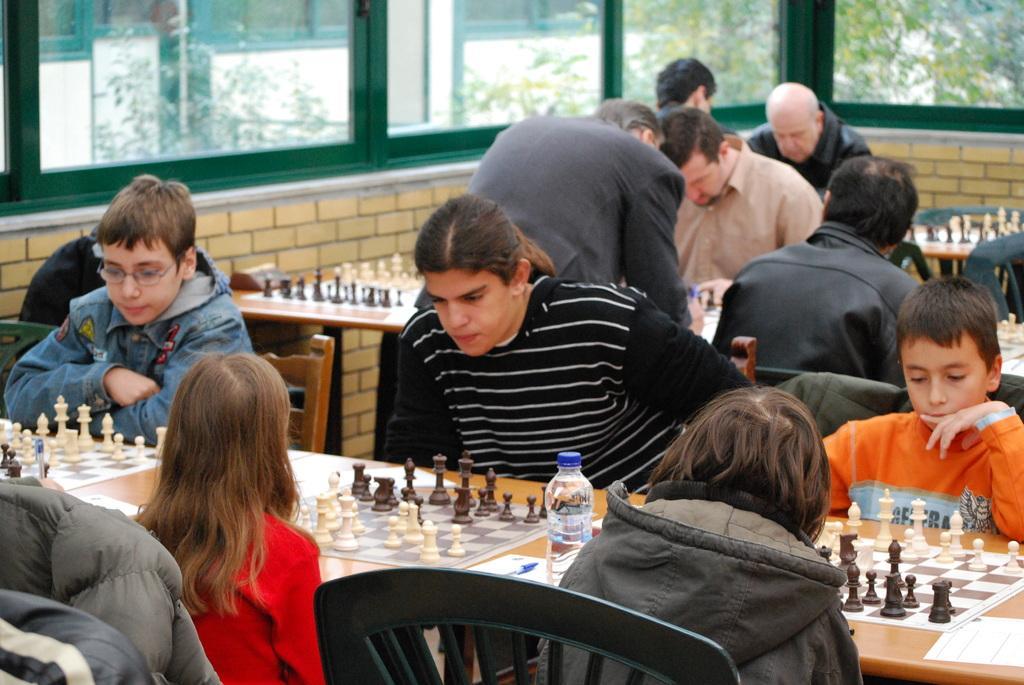Describe this image in one or two sentences. People are playing chess in a hall. They are of different age groups. Children are playing in the front and the older people are playing in the back. There is a glass frame around the hall. Through the glass we can see some trees outside. 